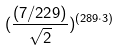<formula> <loc_0><loc_0><loc_500><loc_500>( \frac { ( 7 / 2 2 9 ) } { \sqrt { 2 } } ) ^ { ( 2 8 9 \cdot 3 ) }</formula> 